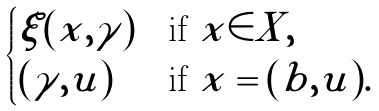Convert formula to latex. <formula><loc_0><loc_0><loc_500><loc_500>\begin{cases} \xi ( x , \gamma ) & \text {if $x\in X$} , \\ ( \gamma , u ) & \text {if $x=(b,u)$} . \end{cases}</formula> 